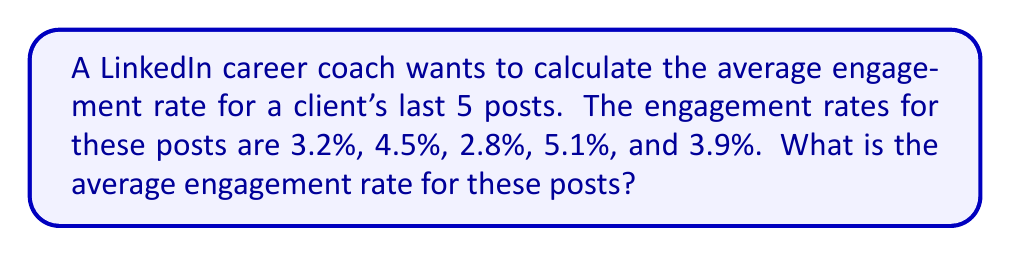Give your solution to this math problem. To calculate the average engagement rate, we need to follow these steps:

1. Sum up all the engagement rates:
   $3.2\% + 4.5\% + 2.8\% + 5.1\% + 3.9\%$

2. Convert percentages to decimals:
   $0.032 + 0.045 + 0.028 + 0.051 + 0.039$

3. Calculate the sum:
   $0.032 + 0.045 + 0.028 + 0.051 + 0.039 = 0.195$

4. Divide the sum by the number of posts (5):
   $$\frac{0.195}{5} = 0.039$$

5. Convert the result back to a percentage:
   $0.039 \times 100\% = 3.9\%$

Therefore, the average engagement rate for the client's last 5 posts is 3.9%.
Answer: 3.9% 